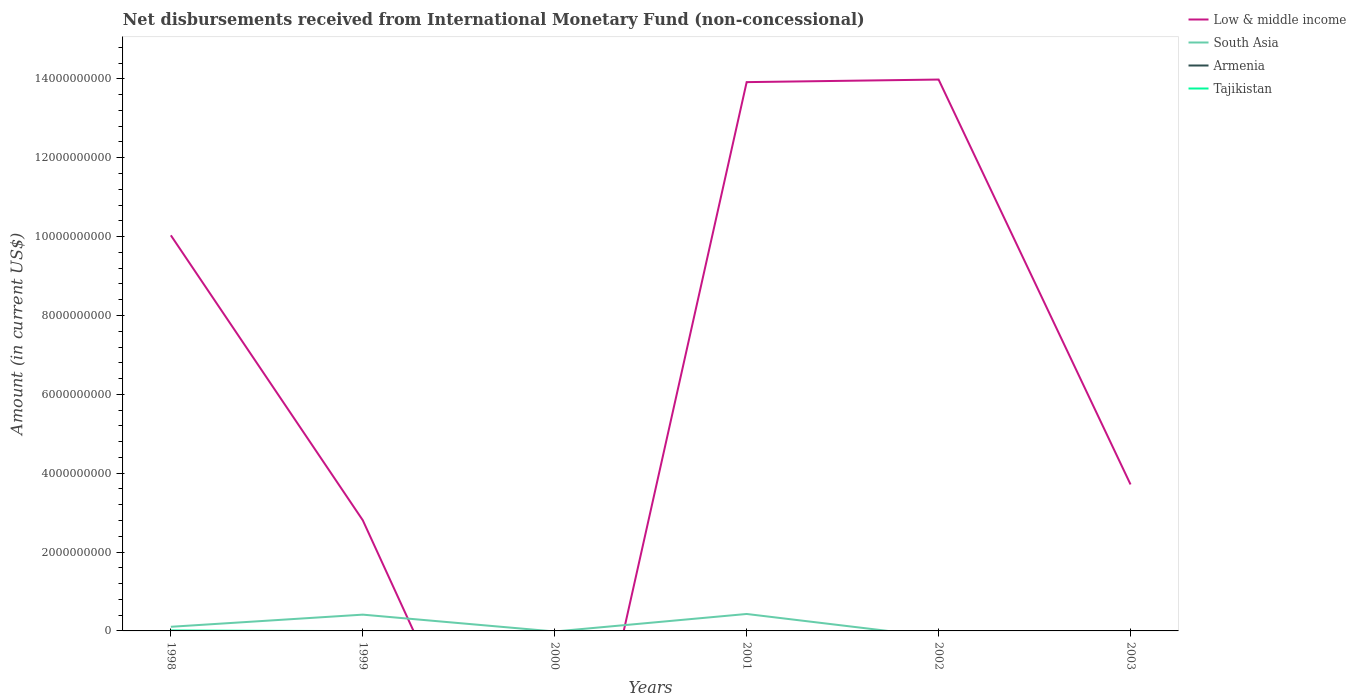Does the line corresponding to Tajikistan intersect with the line corresponding to South Asia?
Keep it short and to the point. Yes. Is the number of lines equal to the number of legend labels?
Make the answer very short. No. What is the total amount of disbursements received from International Monetary Fund in Low & middle income in the graph?
Your answer should be very brief. -6.55e+07. What is the difference between the highest and the second highest amount of disbursements received from International Monetary Fund in Tajikistan?
Provide a succinct answer. 1.02e+07. How many lines are there?
Your response must be concise. 3. How many years are there in the graph?
Offer a terse response. 6. What is the difference between two consecutive major ticks on the Y-axis?
Keep it short and to the point. 2.00e+09. Are the values on the major ticks of Y-axis written in scientific E-notation?
Your answer should be compact. No. Does the graph contain any zero values?
Provide a succinct answer. Yes. How are the legend labels stacked?
Keep it short and to the point. Vertical. What is the title of the graph?
Keep it short and to the point. Net disbursements received from International Monetary Fund (non-concessional). Does "Micronesia" appear as one of the legend labels in the graph?
Your answer should be very brief. No. What is the label or title of the Y-axis?
Give a very brief answer. Amount (in current US$). What is the Amount (in current US$) in Low & middle income in 1998?
Provide a succinct answer. 1.00e+1. What is the Amount (in current US$) in South Asia in 1998?
Ensure brevity in your answer.  1.05e+08. What is the Amount (in current US$) of Tajikistan in 1998?
Your answer should be very brief. 1.02e+07. What is the Amount (in current US$) of Low & middle income in 1999?
Provide a succinct answer. 2.81e+09. What is the Amount (in current US$) of South Asia in 1999?
Your answer should be compact. 4.13e+08. What is the Amount (in current US$) of Low & middle income in 2000?
Provide a short and direct response. 0. What is the Amount (in current US$) in South Asia in 2000?
Ensure brevity in your answer.  0. What is the Amount (in current US$) of Armenia in 2000?
Your answer should be compact. 0. What is the Amount (in current US$) in Tajikistan in 2000?
Keep it short and to the point. 0. What is the Amount (in current US$) of Low & middle income in 2001?
Make the answer very short. 1.39e+1. What is the Amount (in current US$) in South Asia in 2001?
Provide a succinct answer. 4.30e+08. What is the Amount (in current US$) of Tajikistan in 2001?
Offer a very short reply. 0. What is the Amount (in current US$) in Low & middle income in 2002?
Your response must be concise. 1.40e+1. What is the Amount (in current US$) in Low & middle income in 2003?
Ensure brevity in your answer.  3.71e+09. What is the Amount (in current US$) of Armenia in 2003?
Ensure brevity in your answer.  0. What is the Amount (in current US$) in Tajikistan in 2003?
Give a very brief answer. 0. Across all years, what is the maximum Amount (in current US$) of Low & middle income?
Offer a very short reply. 1.40e+1. Across all years, what is the maximum Amount (in current US$) of South Asia?
Keep it short and to the point. 4.30e+08. Across all years, what is the maximum Amount (in current US$) in Tajikistan?
Your answer should be very brief. 1.02e+07. Across all years, what is the minimum Amount (in current US$) of Low & middle income?
Offer a terse response. 0. Across all years, what is the minimum Amount (in current US$) of South Asia?
Provide a succinct answer. 0. What is the total Amount (in current US$) in Low & middle income in the graph?
Make the answer very short. 4.45e+1. What is the total Amount (in current US$) in South Asia in the graph?
Your answer should be compact. 9.48e+08. What is the total Amount (in current US$) in Armenia in the graph?
Offer a very short reply. 0. What is the total Amount (in current US$) in Tajikistan in the graph?
Give a very brief answer. 1.02e+07. What is the difference between the Amount (in current US$) in Low & middle income in 1998 and that in 1999?
Offer a terse response. 7.23e+09. What is the difference between the Amount (in current US$) of South Asia in 1998 and that in 1999?
Offer a terse response. -3.08e+08. What is the difference between the Amount (in current US$) in Low & middle income in 1998 and that in 2001?
Your answer should be compact. -3.89e+09. What is the difference between the Amount (in current US$) of South Asia in 1998 and that in 2001?
Provide a short and direct response. -3.25e+08. What is the difference between the Amount (in current US$) in Low & middle income in 1998 and that in 2002?
Provide a short and direct response. -3.95e+09. What is the difference between the Amount (in current US$) of Low & middle income in 1998 and that in 2003?
Keep it short and to the point. 6.32e+09. What is the difference between the Amount (in current US$) of Low & middle income in 1999 and that in 2001?
Make the answer very short. -1.11e+1. What is the difference between the Amount (in current US$) of South Asia in 1999 and that in 2001?
Ensure brevity in your answer.  -1.68e+07. What is the difference between the Amount (in current US$) of Low & middle income in 1999 and that in 2002?
Offer a terse response. -1.12e+1. What is the difference between the Amount (in current US$) of Low & middle income in 1999 and that in 2003?
Provide a short and direct response. -9.08e+08. What is the difference between the Amount (in current US$) in Low & middle income in 2001 and that in 2002?
Your response must be concise. -6.55e+07. What is the difference between the Amount (in current US$) in Low & middle income in 2001 and that in 2003?
Keep it short and to the point. 1.02e+1. What is the difference between the Amount (in current US$) in Low & middle income in 2002 and that in 2003?
Keep it short and to the point. 1.03e+1. What is the difference between the Amount (in current US$) in Low & middle income in 1998 and the Amount (in current US$) in South Asia in 1999?
Your response must be concise. 9.62e+09. What is the difference between the Amount (in current US$) of Low & middle income in 1998 and the Amount (in current US$) of South Asia in 2001?
Make the answer very short. 9.60e+09. What is the difference between the Amount (in current US$) in Low & middle income in 1999 and the Amount (in current US$) in South Asia in 2001?
Your answer should be compact. 2.38e+09. What is the average Amount (in current US$) of Low & middle income per year?
Give a very brief answer. 7.41e+09. What is the average Amount (in current US$) of South Asia per year?
Offer a terse response. 1.58e+08. What is the average Amount (in current US$) in Tajikistan per year?
Keep it short and to the point. 1.70e+06. In the year 1998, what is the difference between the Amount (in current US$) in Low & middle income and Amount (in current US$) in South Asia?
Provide a succinct answer. 9.93e+09. In the year 1998, what is the difference between the Amount (in current US$) in Low & middle income and Amount (in current US$) in Tajikistan?
Keep it short and to the point. 1.00e+1. In the year 1998, what is the difference between the Amount (in current US$) in South Asia and Amount (in current US$) in Tajikistan?
Your answer should be very brief. 9.48e+07. In the year 1999, what is the difference between the Amount (in current US$) in Low & middle income and Amount (in current US$) in South Asia?
Provide a succinct answer. 2.39e+09. In the year 2001, what is the difference between the Amount (in current US$) in Low & middle income and Amount (in current US$) in South Asia?
Provide a short and direct response. 1.35e+1. What is the ratio of the Amount (in current US$) in Low & middle income in 1998 to that in 1999?
Keep it short and to the point. 3.57. What is the ratio of the Amount (in current US$) in South Asia in 1998 to that in 1999?
Offer a terse response. 0.25. What is the ratio of the Amount (in current US$) of Low & middle income in 1998 to that in 2001?
Provide a short and direct response. 0.72. What is the ratio of the Amount (in current US$) of South Asia in 1998 to that in 2001?
Your answer should be compact. 0.24. What is the ratio of the Amount (in current US$) of Low & middle income in 1998 to that in 2002?
Offer a terse response. 0.72. What is the ratio of the Amount (in current US$) in Low & middle income in 1998 to that in 2003?
Offer a terse response. 2.7. What is the ratio of the Amount (in current US$) of Low & middle income in 1999 to that in 2001?
Provide a short and direct response. 0.2. What is the ratio of the Amount (in current US$) in South Asia in 1999 to that in 2001?
Your answer should be compact. 0.96. What is the ratio of the Amount (in current US$) in Low & middle income in 1999 to that in 2002?
Keep it short and to the point. 0.2. What is the ratio of the Amount (in current US$) in Low & middle income in 1999 to that in 2003?
Ensure brevity in your answer.  0.76. What is the ratio of the Amount (in current US$) in Low & middle income in 2001 to that in 2003?
Offer a very short reply. 3.75. What is the ratio of the Amount (in current US$) of Low & middle income in 2002 to that in 2003?
Provide a succinct answer. 3.76. What is the difference between the highest and the second highest Amount (in current US$) in Low & middle income?
Give a very brief answer. 6.55e+07. What is the difference between the highest and the second highest Amount (in current US$) in South Asia?
Offer a terse response. 1.68e+07. What is the difference between the highest and the lowest Amount (in current US$) in Low & middle income?
Ensure brevity in your answer.  1.40e+1. What is the difference between the highest and the lowest Amount (in current US$) of South Asia?
Your response must be concise. 4.30e+08. What is the difference between the highest and the lowest Amount (in current US$) in Tajikistan?
Provide a short and direct response. 1.02e+07. 